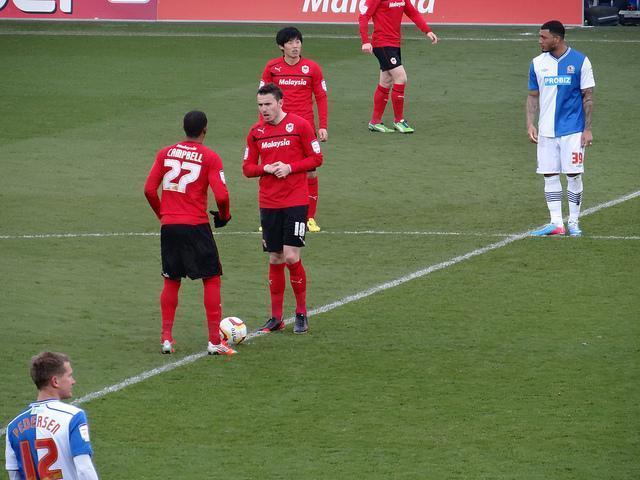How many people are there?
Give a very brief answer. 5. 